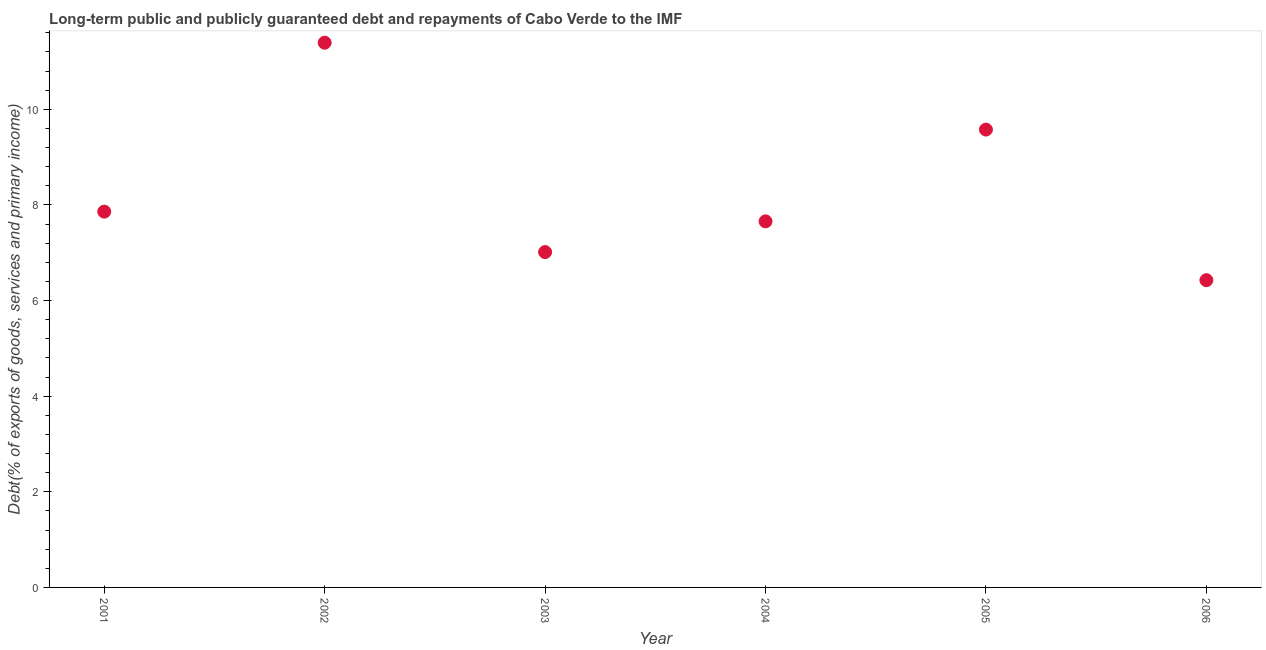What is the debt service in 2005?
Keep it short and to the point. 9.58. Across all years, what is the maximum debt service?
Provide a succinct answer. 11.39. Across all years, what is the minimum debt service?
Offer a very short reply. 6.43. What is the sum of the debt service?
Ensure brevity in your answer.  49.93. What is the difference between the debt service in 2002 and 2006?
Make the answer very short. 4.97. What is the average debt service per year?
Make the answer very short. 8.32. What is the median debt service?
Ensure brevity in your answer.  7.76. In how many years, is the debt service greater than 5.6 %?
Provide a succinct answer. 6. Do a majority of the years between 2002 and 2005 (inclusive) have debt service greater than 3.2 %?
Provide a short and direct response. Yes. What is the ratio of the debt service in 2001 to that in 2006?
Offer a terse response. 1.22. Is the difference between the debt service in 2003 and 2005 greater than the difference between any two years?
Your answer should be compact. No. What is the difference between the highest and the second highest debt service?
Offer a very short reply. 1.82. Is the sum of the debt service in 2002 and 2003 greater than the maximum debt service across all years?
Provide a succinct answer. Yes. What is the difference between the highest and the lowest debt service?
Make the answer very short. 4.97. In how many years, is the debt service greater than the average debt service taken over all years?
Give a very brief answer. 2. Does the debt service monotonically increase over the years?
Give a very brief answer. No. How many years are there in the graph?
Keep it short and to the point. 6. What is the title of the graph?
Your answer should be very brief. Long-term public and publicly guaranteed debt and repayments of Cabo Verde to the IMF. What is the label or title of the Y-axis?
Ensure brevity in your answer.  Debt(% of exports of goods, services and primary income). What is the Debt(% of exports of goods, services and primary income) in 2001?
Your answer should be compact. 7.86. What is the Debt(% of exports of goods, services and primary income) in 2002?
Provide a short and direct response. 11.39. What is the Debt(% of exports of goods, services and primary income) in 2003?
Your response must be concise. 7.01. What is the Debt(% of exports of goods, services and primary income) in 2004?
Offer a terse response. 7.66. What is the Debt(% of exports of goods, services and primary income) in 2005?
Offer a very short reply. 9.58. What is the Debt(% of exports of goods, services and primary income) in 2006?
Give a very brief answer. 6.43. What is the difference between the Debt(% of exports of goods, services and primary income) in 2001 and 2002?
Offer a terse response. -3.53. What is the difference between the Debt(% of exports of goods, services and primary income) in 2001 and 2003?
Provide a short and direct response. 0.85. What is the difference between the Debt(% of exports of goods, services and primary income) in 2001 and 2004?
Offer a terse response. 0.2. What is the difference between the Debt(% of exports of goods, services and primary income) in 2001 and 2005?
Provide a succinct answer. -1.72. What is the difference between the Debt(% of exports of goods, services and primary income) in 2001 and 2006?
Keep it short and to the point. 1.43. What is the difference between the Debt(% of exports of goods, services and primary income) in 2002 and 2003?
Make the answer very short. 4.38. What is the difference between the Debt(% of exports of goods, services and primary income) in 2002 and 2004?
Provide a short and direct response. 3.74. What is the difference between the Debt(% of exports of goods, services and primary income) in 2002 and 2005?
Your answer should be compact. 1.82. What is the difference between the Debt(% of exports of goods, services and primary income) in 2002 and 2006?
Your answer should be compact. 4.97. What is the difference between the Debt(% of exports of goods, services and primary income) in 2003 and 2004?
Offer a very short reply. -0.64. What is the difference between the Debt(% of exports of goods, services and primary income) in 2003 and 2005?
Offer a terse response. -2.56. What is the difference between the Debt(% of exports of goods, services and primary income) in 2003 and 2006?
Offer a very short reply. 0.59. What is the difference between the Debt(% of exports of goods, services and primary income) in 2004 and 2005?
Your answer should be compact. -1.92. What is the difference between the Debt(% of exports of goods, services and primary income) in 2004 and 2006?
Make the answer very short. 1.23. What is the difference between the Debt(% of exports of goods, services and primary income) in 2005 and 2006?
Provide a short and direct response. 3.15. What is the ratio of the Debt(% of exports of goods, services and primary income) in 2001 to that in 2002?
Your response must be concise. 0.69. What is the ratio of the Debt(% of exports of goods, services and primary income) in 2001 to that in 2003?
Provide a succinct answer. 1.12. What is the ratio of the Debt(% of exports of goods, services and primary income) in 2001 to that in 2005?
Provide a short and direct response. 0.82. What is the ratio of the Debt(% of exports of goods, services and primary income) in 2001 to that in 2006?
Ensure brevity in your answer.  1.22. What is the ratio of the Debt(% of exports of goods, services and primary income) in 2002 to that in 2003?
Offer a very short reply. 1.62. What is the ratio of the Debt(% of exports of goods, services and primary income) in 2002 to that in 2004?
Offer a terse response. 1.49. What is the ratio of the Debt(% of exports of goods, services and primary income) in 2002 to that in 2005?
Make the answer very short. 1.19. What is the ratio of the Debt(% of exports of goods, services and primary income) in 2002 to that in 2006?
Offer a very short reply. 1.77. What is the ratio of the Debt(% of exports of goods, services and primary income) in 2003 to that in 2004?
Your response must be concise. 0.92. What is the ratio of the Debt(% of exports of goods, services and primary income) in 2003 to that in 2005?
Give a very brief answer. 0.73. What is the ratio of the Debt(% of exports of goods, services and primary income) in 2003 to that in 2006?
Your answer should be compact. 1.09. What is the ratio of the Debt(% of exports of goods, services and primary income) in 2004 to that in 2005?
Provide a succinct answer. 0.8. What is the ratio of the Debt(% of exports of goods, services and primary income) in 2004 to that in 2006?
Provide a succinct answer. 1.19. What is the ratio of the Debt(% of exports of goods, services and primary income) in 2005 to that in 2006?
Keep it short and to the point. 1.49. 